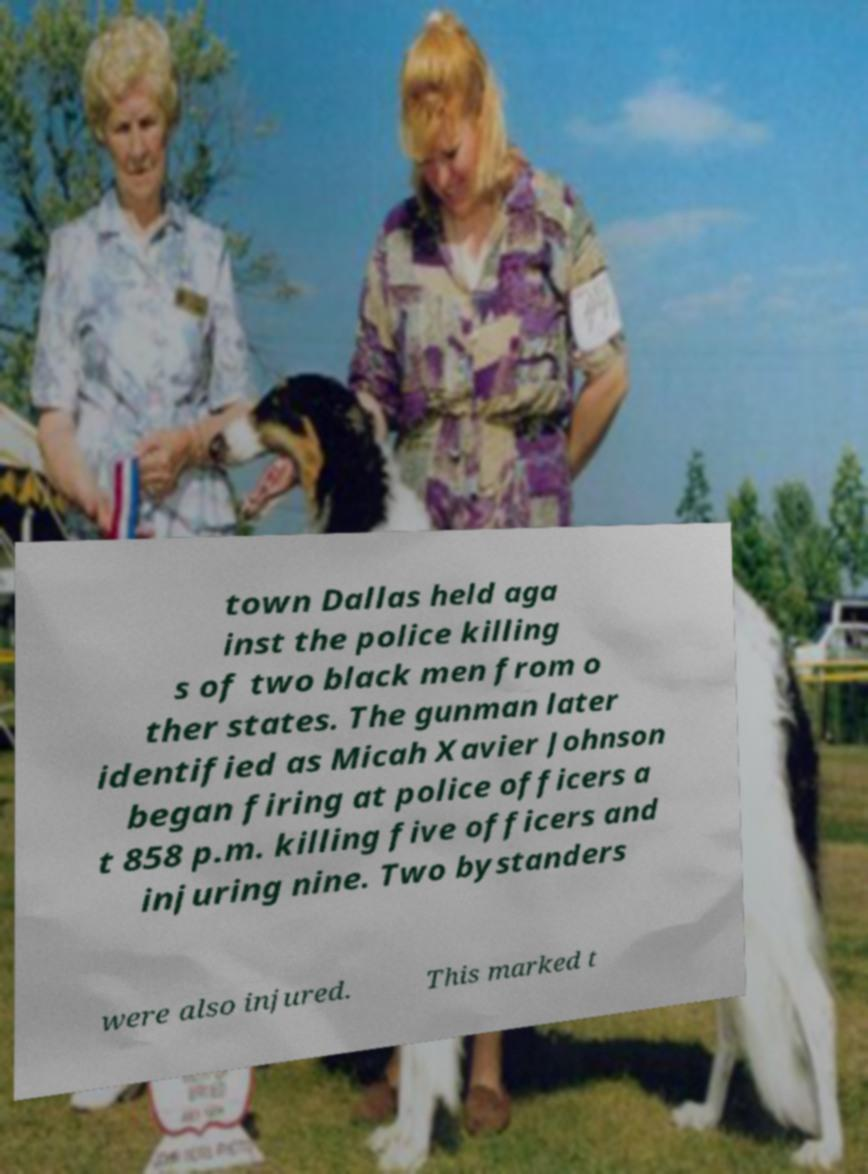Could you assist in decoding the text presented in this image and type it out clearly? town Dallas held aga inst the police killing s of two black men from o ther states. The gunman later identified as Micah Xavier Johnson began firing at police officers a t 858 p.m. killing five officers and injuring nine. Two bystanders were also injured. This marked t 